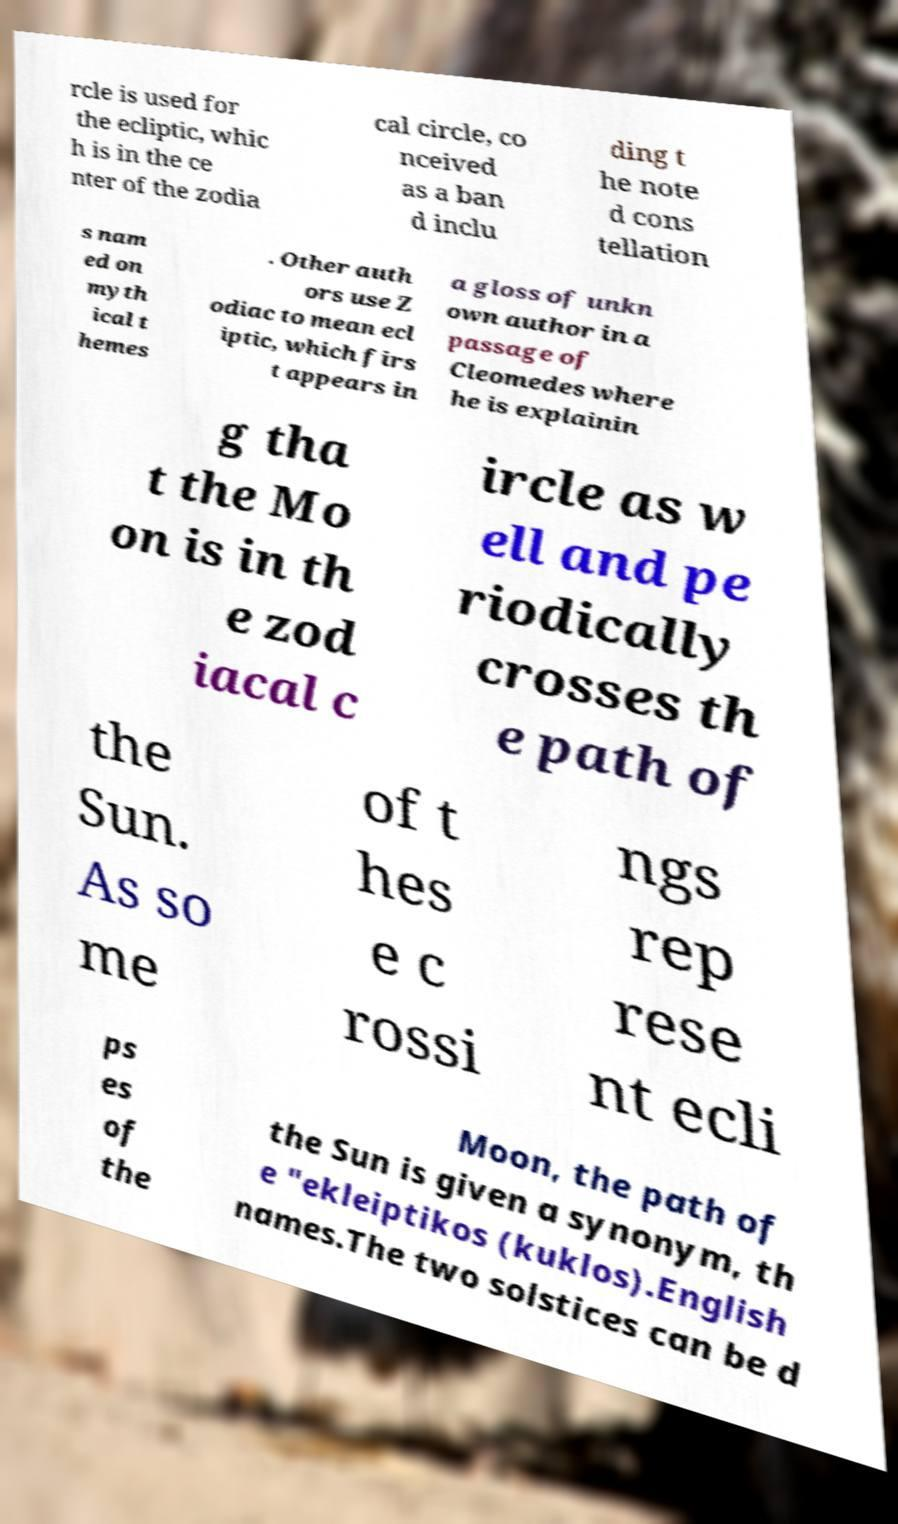For documentation purposes, I need the text within this image transcribed. Could you provide that? rcle is used for the ecliptic, whic h is in the ce nter of the zodia cal circle, co nceived as a ban d inclu ding t he note d cons tellation s nam ed on myth ical t hemes . Other auth ors use Z odiac to mean ecl iptic, which firs t appears in a gloss of unkn own author in a passage of Cleomedes where he is explainin g tha t the Mo on is in th e zod iacal c ircle as w ell and pe riodically crosses th e path of the Sun. As so me of t hes e c rossi ngs rep rese nt ecli ps es of the Moon, the path of the Sun is given a synonym, th e "ekleiptikos (kuklos).English names.The two solstices can be d 